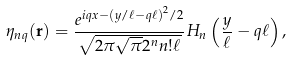<formula> <loc_0><loc_0><loc_500><loc_500>\eta _ { n q } ( \mathbf r ) = \frac { e ^ { i q x - \left ( y / \ell - q \ell \right ) ^ { 2 } / 2 } } { \sqrt { 2 \pi \sqrt { \pi } 2 ^ { n } n ! \ell } } H _ { n } \left ( \frac { y } { \ell } - q \ell \right ) ,</formula> 